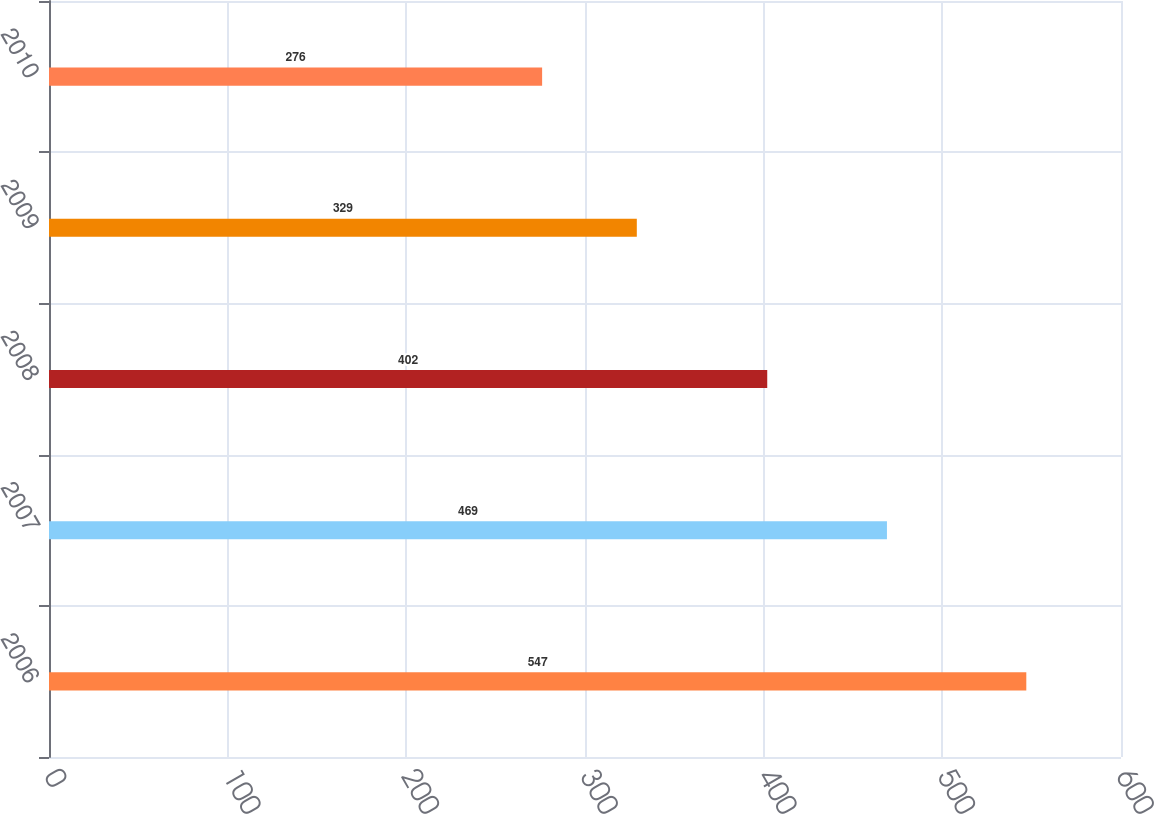Convert chart. <chart><loc_0><loc_0><loc_500><loc_500><bar_chart><fcel>2006<fcel>2007<fcel>2008<fcel>2009<fcel>2010<nl><fcel>547<fcel>469<fcel>402<fcel>329<fcel>276<nl></chart> 